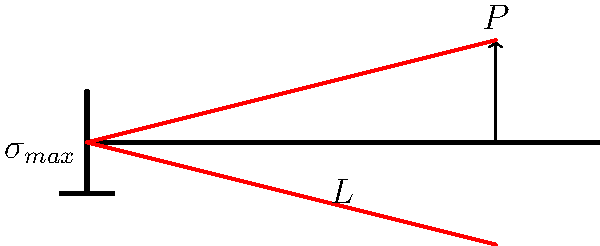In your latest visual effects project, you're simulating the bending of a futuristic cantilever beam. The beam is subjected to a point load $P$ at its free end. If the beam has a length $L$ and a rectangular cross-section with width $b$ and height $h$, derive an expression for the maximum bending stress $\sigma_{max}$ at the fixed end in terms of $P$, $L$, $b$, and $h$. How does this stress distribution contribute to the visual realism of your CGI model? To derive the expression for maximum bending stress, we'll follow these steps:

1) The maximum bending moment $M_{max}$ occurs at the fixed end of the cantilever beam:
   $M_{max} = PL$

2) For a rectangular cross-section, the moment of inertia $I$ is:
   $I = \frac{bh^3}{12}$

3) The distance from the neutral axis to the outermost fiber $c$ is:
   $c = \frac{h}{2}$

4) The general equation for bending stress is:
   $\sigma = \frac{Mc}{I}$

5) Substituting the values we found in steps 1-3 into this equation:
   $\sigma_{max} = \frac{PL \cdot \frac{h}{2}}{\frac{bh^3}{12}}$

6) Simplifying:
   $\sigma_{max} = \frac{6PL}{bh^2}$

This stress distribution contributes to visual realism by accurately representing how the beam would deform under load. The linear stress distribution shown in the diagram (maximum at the surfaces, zero at the neutral axis) allows for realistic bending animations. In CGI, this could be used to drive displacement maps or deformation rigs, ensuring that the beam's curvature and any surface details (like paint cracking) respond correctly to the applied load.
Answer: $\sigma_{max} = \frac{6PL}{bh^2}$ 